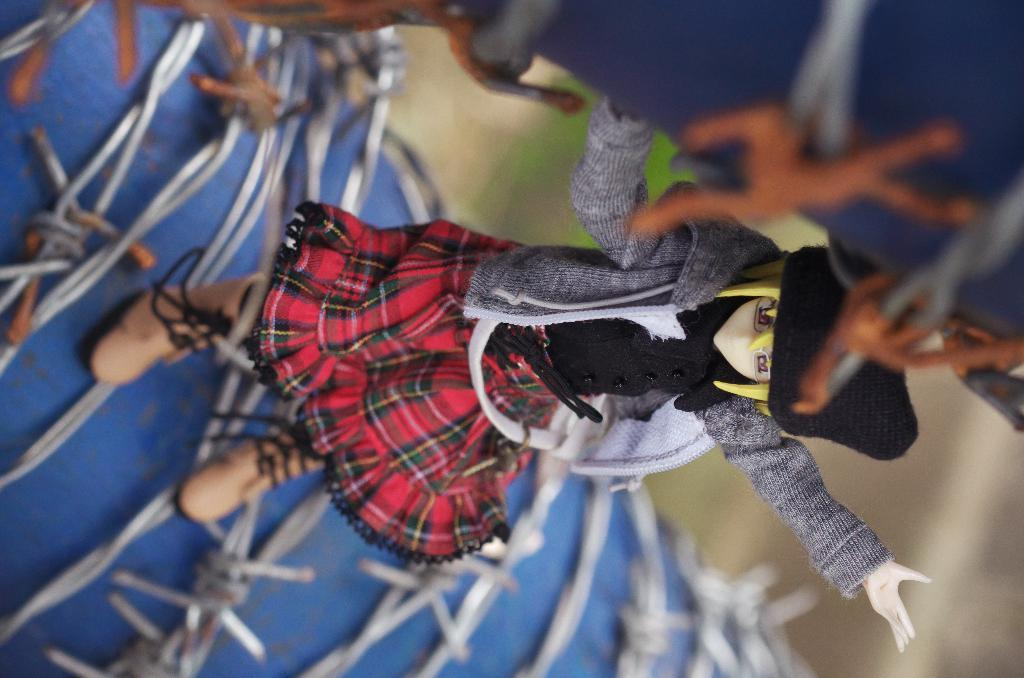What is the main subject in the image? There is a doll in the image. What is the doll placed on? The doll is on a blue object. Can you describe the background of the image? The background of the image is blurred. What is the doll's opinion on the dirt in the image? There is no dirt present in the image, and dolls do not have opinions. 